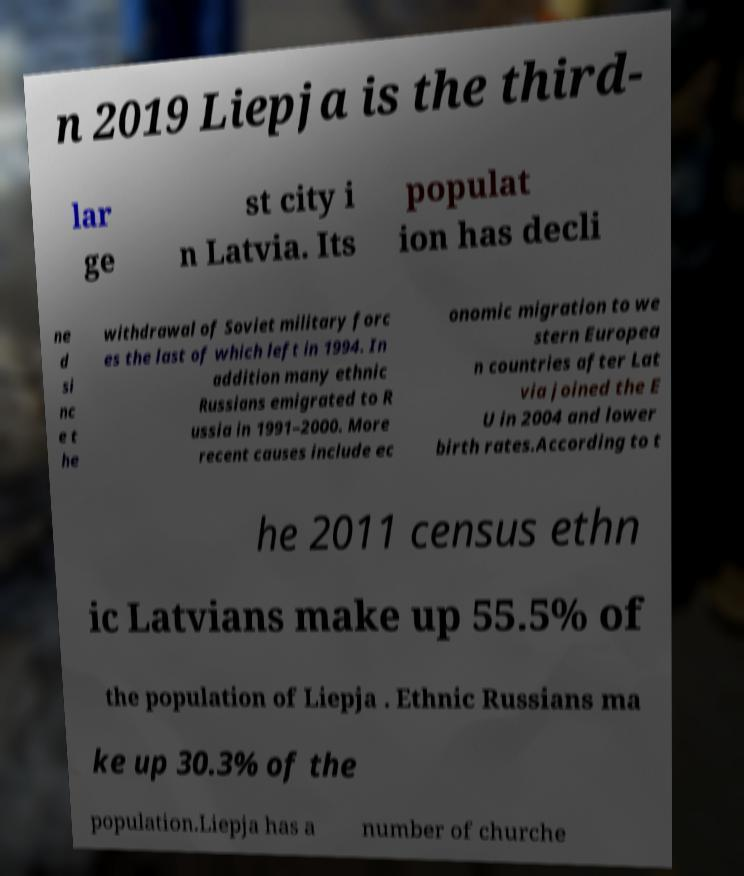For documentation purposes, I need the text within this image transcribed. Could you provide that? n 2019 Liepja is the third- lar ge st city i n Latvia. Its populat ion has decli ne d si nc e t he withdrawal of Soviet military forc es the last of which left in 1994. In addition many ethnic Russians emigrated to R ussia in 1991–2000. More recent causes include ec onomic migration to we stern Europea n countries after Lat via joined the E U in 2004 and lower birth rates.According to t he 2011 census ethn ic Latvians make up 55.5% of the population of Liepja . Ethnic Russians ma ke up 30.3% of the population.Liepja has a number of churche 